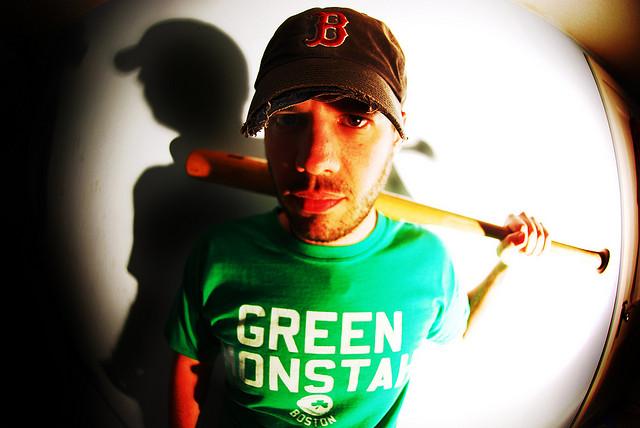What color is the man's shirt?
Be succinct. Green. What is the man holding?
Concise answer only. Bat. What city does this man root for?
Keep it brief. Boston. 